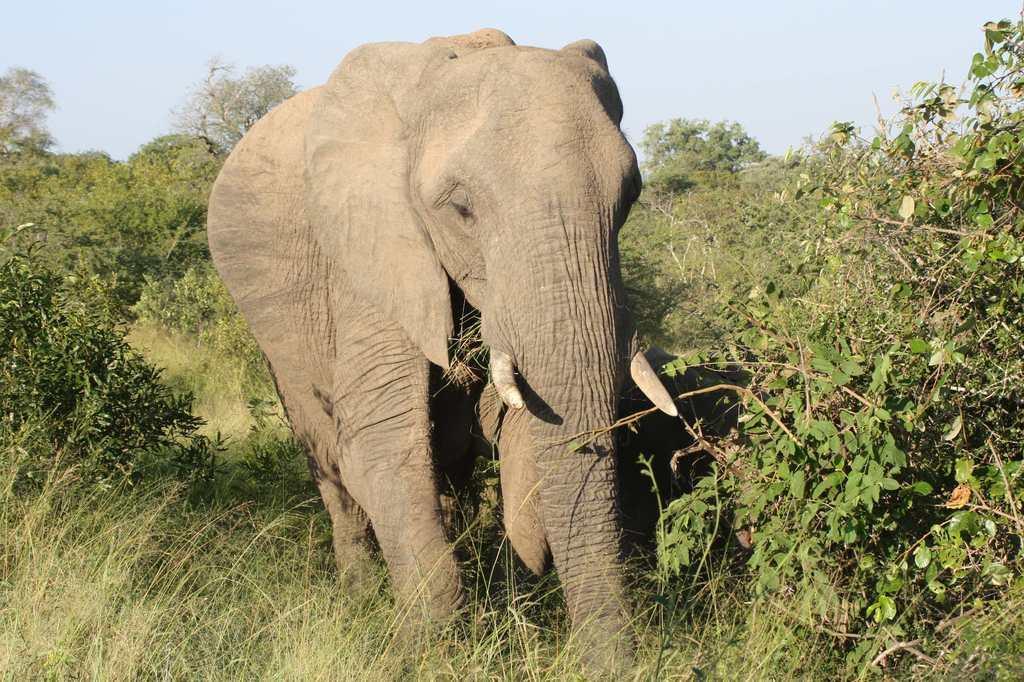Please provide a concise description of this image. In this image we can see an elephant which is walking in the forest and at the background of the image there are some trees and clear sky. 